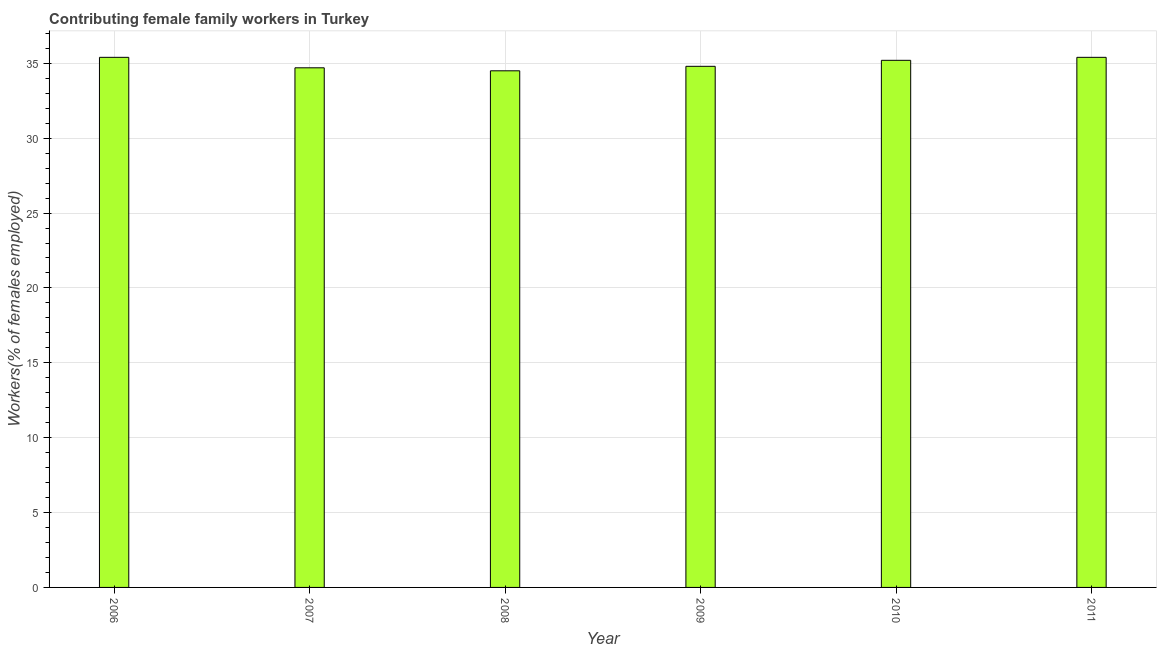What is the title of the graph?
Keep it short and to the point. Contributing female family workers in Turkey. What is the label or title of the Y-axis?
Your answer should be compact. Workers(% of females employed). What is the contributing female family workers in 2011?
Provide a succinct answer. 35.4. Across all years, what is the maximum contributing female family workers?
Ensure brevity in your answer.  35.4. Across all years, what is the minimum contributing female family workers?
Offer a very short reply. 34.5. In which year was the contributing female family workers maximum?
Your answer should be compact. 2006. What is the sum of the contributing female family workers?
Your answer should be compact. 210. What is the average contributing female family workers per year?
Your answer should be very brief. 35. What is the median contributing female family workers?
Ensure brevity in your answer.  35. In how many years, is the contributing female family workers greater than 5 %?
Ensure brevity in your answer.  6. Do a majority of the years between 2009 and 2006 (inclusive) have contributing female family workers greater than 2 %?
Keep it short and to the point. Yes. Is the difference between the contributing female family workers in 2006 and 2010 greater than the difference between any two years?
Offer a very short reply. No. What is the difference between the highest and the second highest contributing female family workers?
Provide a succinct answer. 0. What is the difference between the highest and the lowest contributing female family workers?
Your answer should be very brief. 0.9. What is the Workers(% of females employed) of 2006?
Your answer should be very brief. 35.4. What is the Workers(% of females employed) in 2007?
Make the answer very short. 34.7. What is the Workers(% of females employed) in 2008?
Give a very brief answer. 34.5. What is the Workers(% of females employed) in 2009?
Keep it short and to the point. 34.8. What is the Workers(% of females employed) of 2010?
Offer a terse response. 35.2. What is the Workers(% of females employed) in 2011?
Ensure brevity in your answer.  35.4. What is the difference between the Workers(% of females employed) in 2006 and 2009?
Your response must be concise. 0.6. What is the difference between the Workers(% of females employed) in 2006 and 2011?
Provide a succinct answer. 0. What is the difference between the Workers(% of females employed) in 2007 and 2009?
Your answer should be compact. -0.1. What is the difference between the Workers(% of females employed) in 2007 and 2011?
Your answer should be compact. -0.7. What is the difference between the Workers(% of females employed) in 2008 and 2010?
Offer a very short reply. -0.7. What is the difference between the Workers(% of females employed) in 2008 and 2011?
Ensure brevity in your answer.  -0.9. What is the difference between the Workers(% of females employed) in 2009 and 2010?
Make the answer very short. -0.4. What is the difference between the Workers(% of females employed) in 2010 and 2011?
Ensure brevity in your answer.  -0.2. What is the ratio of the Workers(% of females employed) in 2006 to that in 2007?
Your response must be concise. 1.02. What is the ratio of the Workers(% of females employed) in 2006 to that in 2009?
Offer a very short reply. 1.02. What is the ratio of the Workers(% of females employed) in 2007 to that in 2010?
Offer a very short reply. 0.99. What is the ratio of the Workers(% of females employed) in 2009 to that in 2011?
Offer a very short reply. 0.98. What is the ratio of the Workers(% of females employed) in 2010 to that in 2011?
Offer a very short reply. 0.99. 